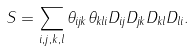Convert formula to latex. <formula><loc_0><loc_0><loc_500><loc_500>S = \sum _ { i , j , k , l } \theta _ { i j k } \theta _ { k l i } D _ { i j } D _ { j k } D _ { k l } D _ { l i } .</formula> 